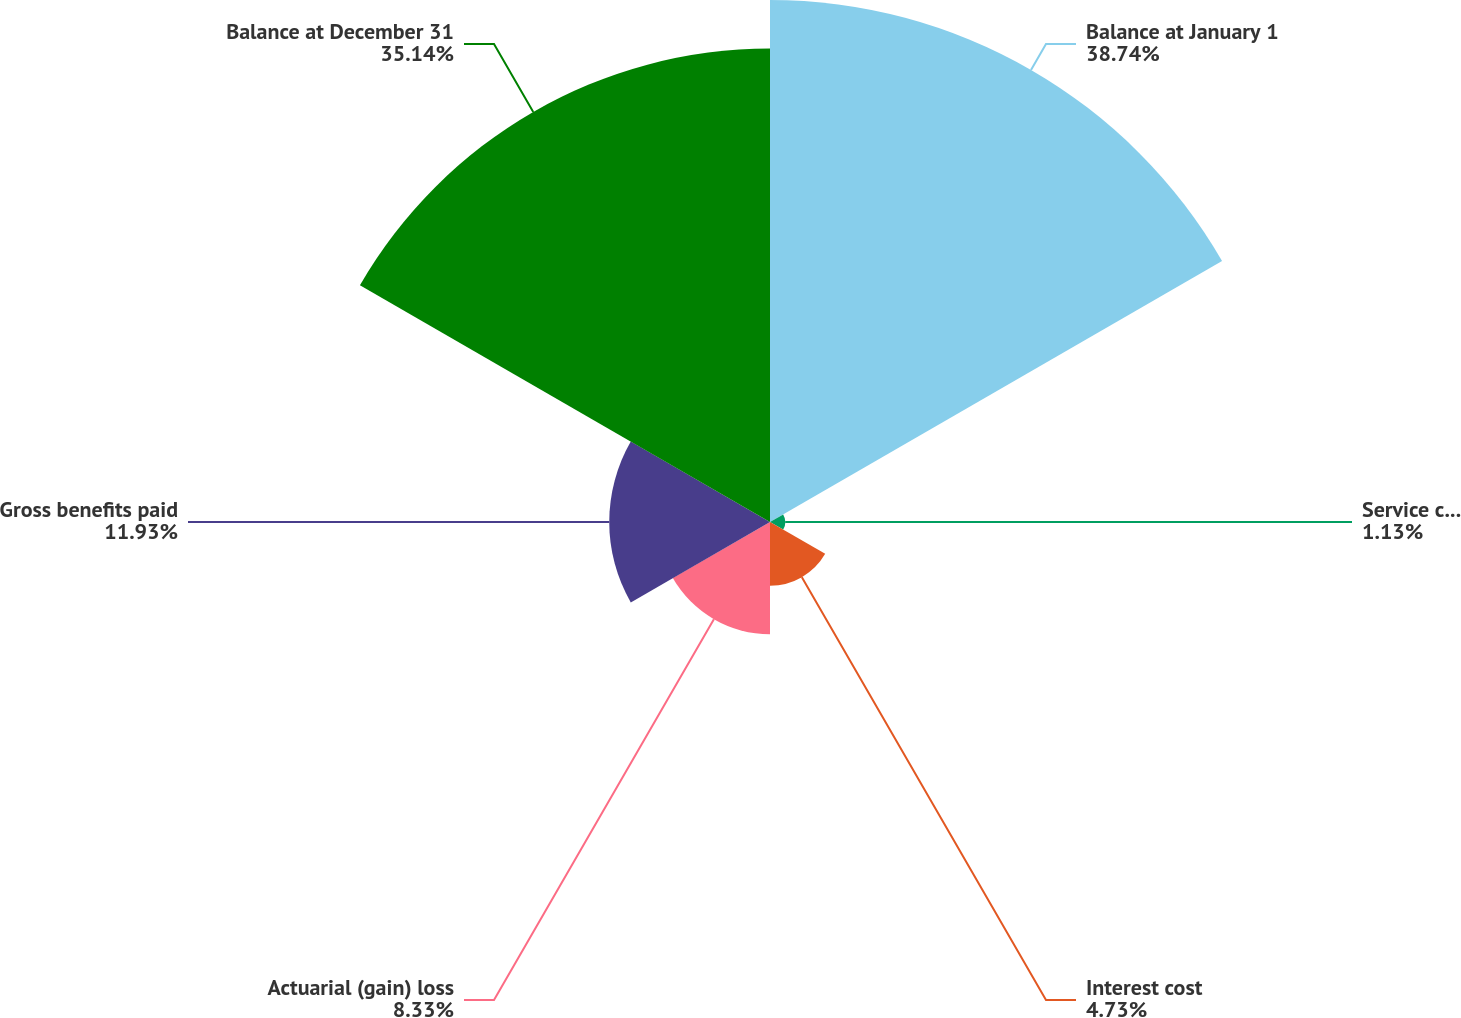Convert chart. <chart><loc_0><loc_0><loc_500><loc_500><pie_chart><fcel>Balance at January 1<fcel>Service cost<fcel>Interest cost<fcel>Actuarial (gain) loss<fcel>Gross benefits paid<fcel>Balance at December 31<nl><fcel>38.74%<fcel>1.13%<fcel>4.73%<fcel>8.33%<fcel>11.93%<fcel>35.14%<nl></chart> 